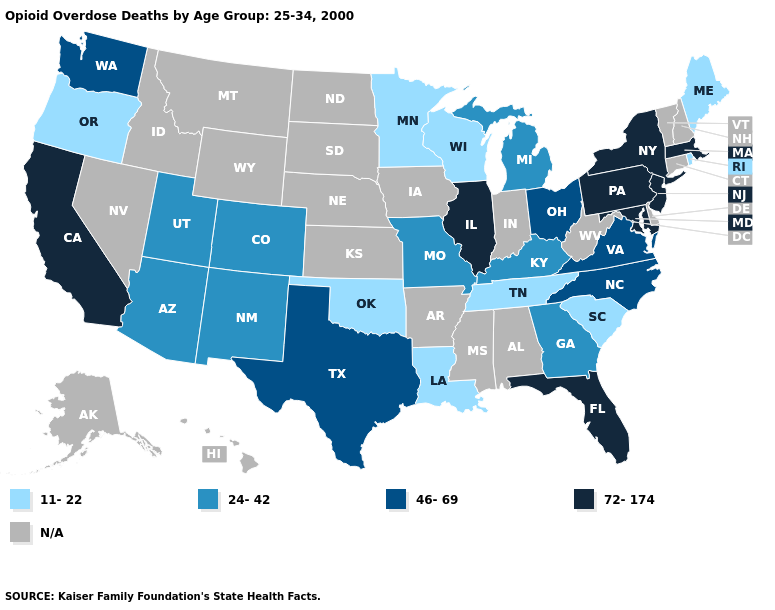Name the states that have a value in the range 72-174?
Answer briefly. California, Florida, Illinois, Maryland, Massachusetts, New Jersey, New York, Pennsylvania. What is the lowest value in the USA?
Short answer required. 11-22. Does Minnesota have the lowest value in the USA?
Be succinct. Yes. Which states have the lowest value in the USA?
Give a very brief answer. Louisiana, Maine, Minnesota, Oklahoma, Oregon, Rhode Island, South Carolina, Tennessee, Wisconsin. What is the value of Georgia?
Be succinct. 24-42. What is the lowest value in the Northeast?
Answer briefly. 11-22. What is the highest value in states that border Arkansas?
Write a very short answer. 46-69. What is the value of Louisiana?
Keep it brief. 11-22. Does Pennsylvania have the highest value in the USA?
Concise answer only. Yes. What is the lowest value in the USA?
Keep it brief. 11-22. Name the states that have a value in the range 46-69?
Short answer required. North Carolina, Ohio, Texas, Virginia, Washington. What is the lowest value in the Northeast?
Keep it brief. 11-22. Name the states that have a value in the range 11-22?
Give a very brief answer. Louisiana, Maine, Minnesota, Oklahoma, Oregon, Rhode Island, South Carolina, Tennessee, Wisconsin. What is the value of Wyoming?
Give a very brief answer. N/A. 